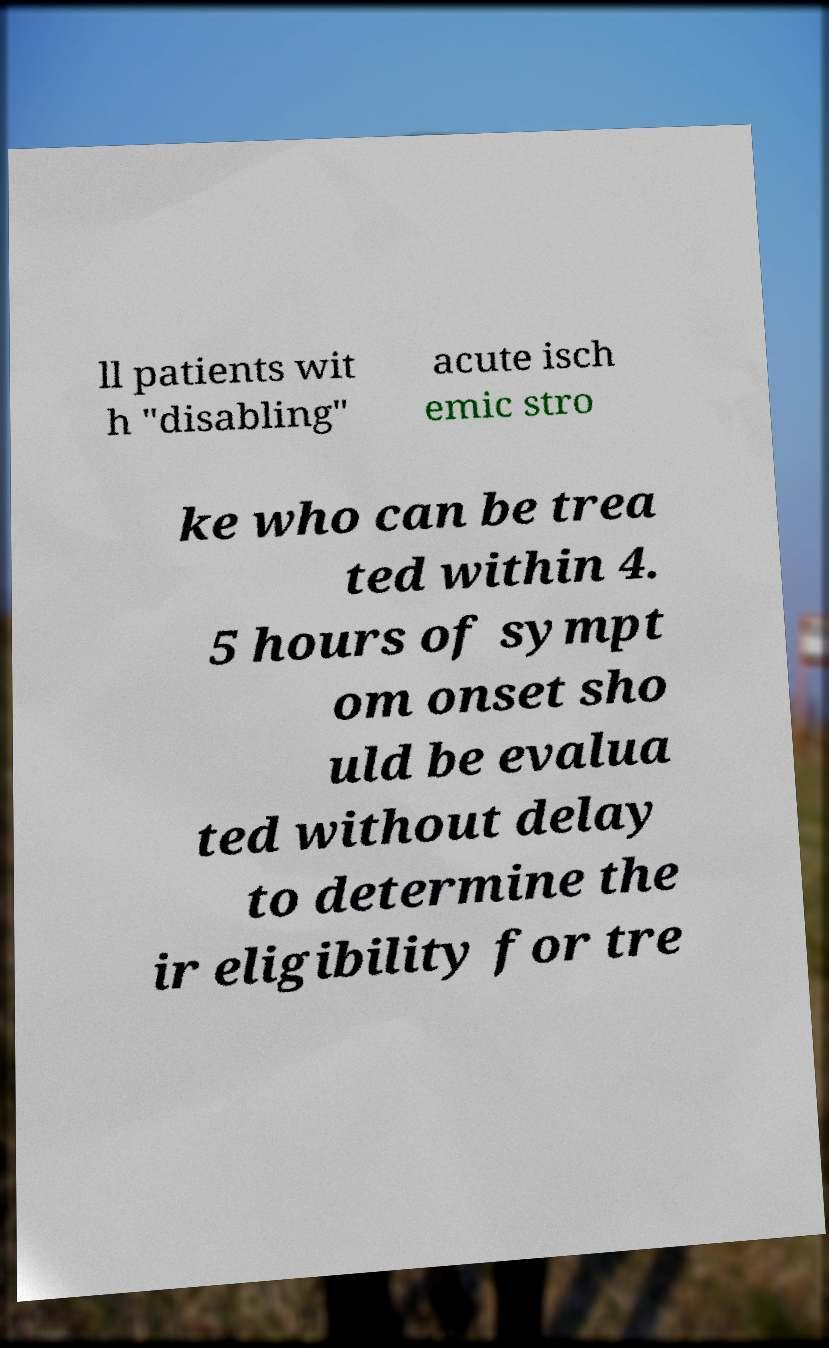I need the written content from this picture converted into text. Can you do that? ll patients wit h "disabling" acute isch emic stro ke who can be trea ted within 4. 5 hours of sympt om onset sho uld be evalua ted without delay to determine the ir eligibility for tre 